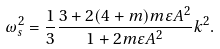Convert formula to latex. <formula><loc_0><loc_0><loc_500><loc_500>\omega _ { s } ^ { 2 } = \frac { 1 } { 3 } \frac { 3 + 2 ( 4 + m ) m \varepsilon A ^ { 2 } } { 1 + 2 m \varepsilon A ^ { 2 } } k ^ { 2 } .</formula> 